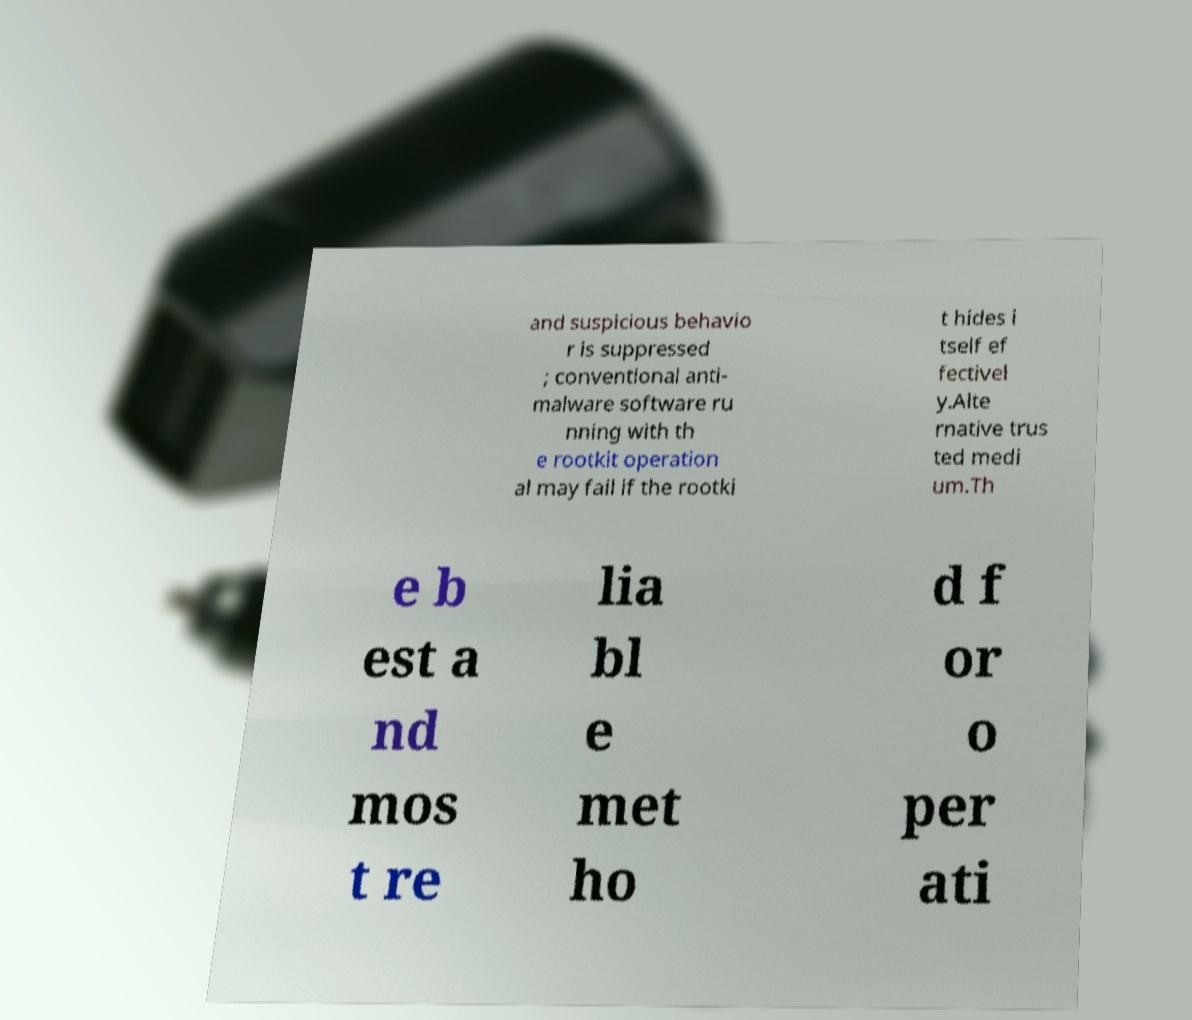Please identify and transcribe the text found in this image. and suspicious behavio r is suppressed ; conventional anti- malware software ru nning with th e rootkit operation al may fail if the rootki t hides i tself ef fectivel y.Alte rnative trus ted medi um.Th e b est a nd mos t re lia bl e met ho d f or o per ati 